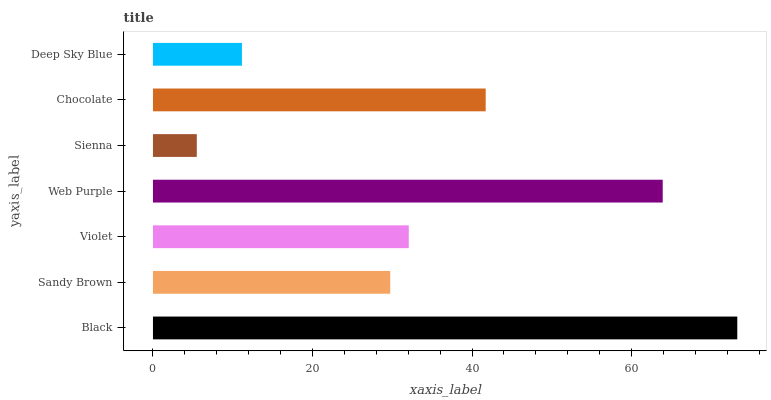Is Sienna the minimum?
Answer yes or no. Yes. Is Black the maximum?
Answer yes or no. Yes. Is Sandy Brown the minimum?
Answer yes or no. No. Is Sandy Brown the maximum?
Answer yes or no. No. Is Black greater than Sandy Brown?
Answer yes or no. Yes. Is Sandy Brown less than Black?
Answer yes or no. Yes. Is Sandy Brown greater than Black?
Answer yes or no. No. Is Black less than Sandy Brown?
Answer yes or no. No. Is Violet the high median?
Answer yes or no. Yes. Is Violet the low median?
Answer yes or no. Yes. Is Deep Sky Blue the high median?
Answer yes or no. No. Is Deep Sky Blue the low median?
Answer yes or no. No. 